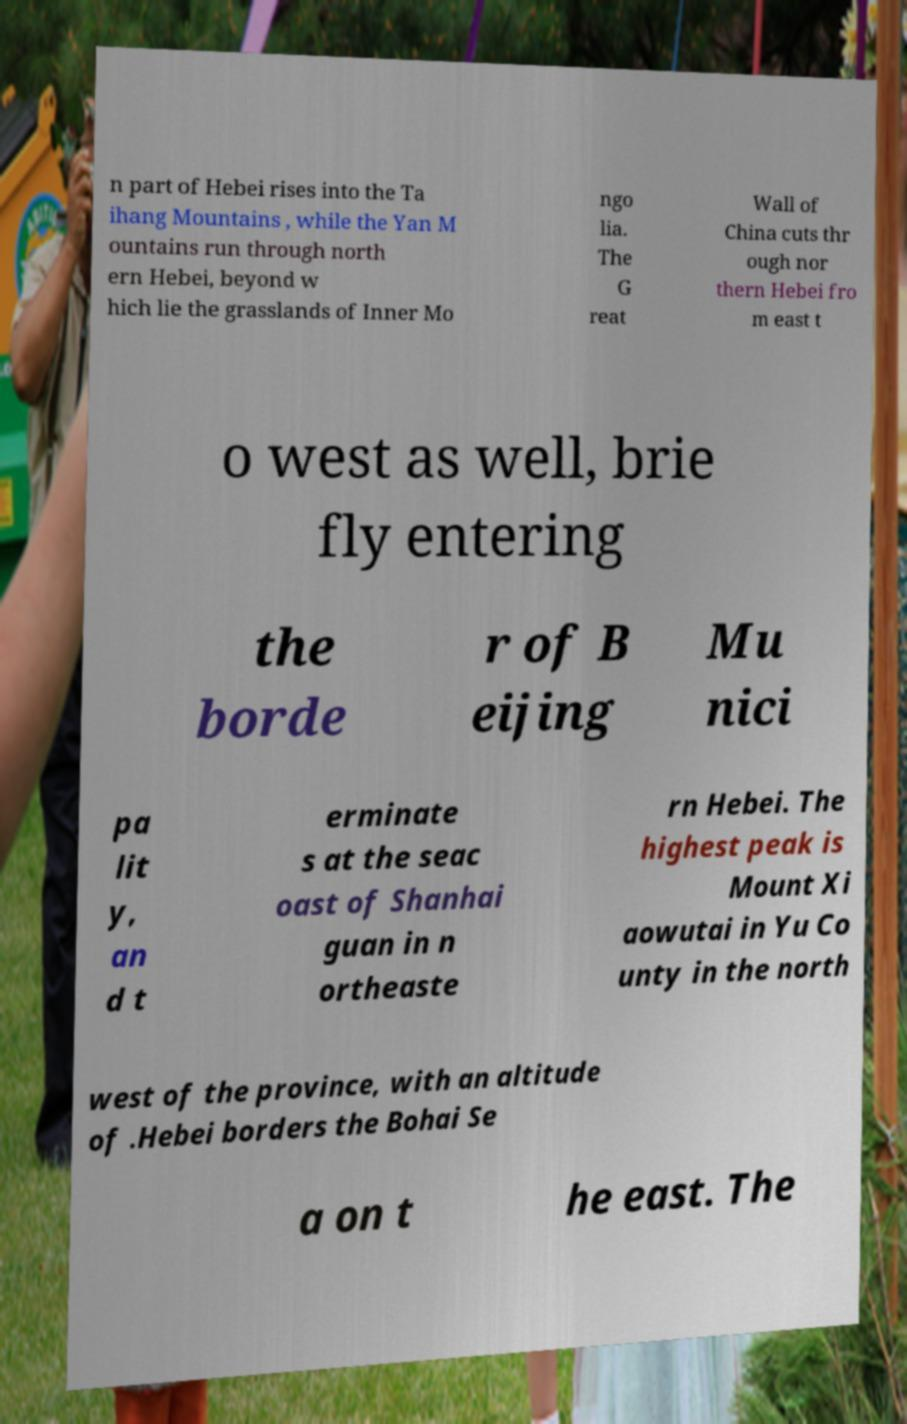I need the written content from this picture converted into text. Can you do that? n part of Hebei rises into the Ta ihang Mountains , while the Yan M ountains run through north ern Hebei, beyond w hich lie the grasslands of Inner Mo ngo lia. The G reat Wall of China cuts thr ough nor thern Hebei fro m east t o west as well, brie fly entering the borde r of B eijing Mu nici pa lit y, an d t erminate s at the seac oast of Shanhai guan in n ortheaste rn Hebei. The highest peak is Mount Xi aowutai in Yu Co unty in the north west of the province, with an altitude of .Hebei borders the Bohai Se a on t he east. The 